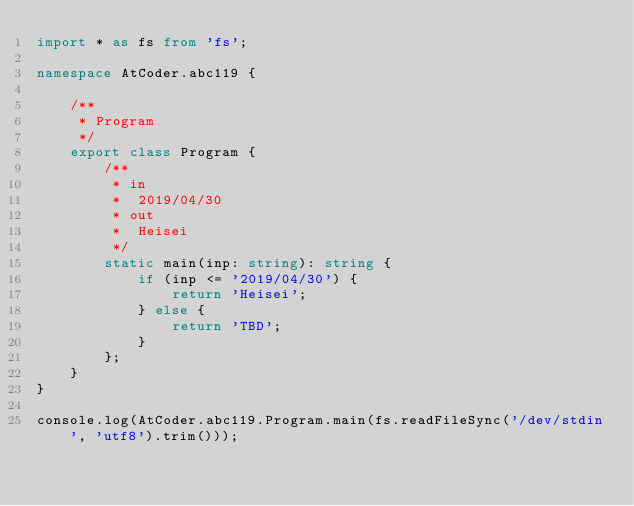Convert code to text. <code><loc_0><loc_0><loc_500><loc_500><_TypeScript_>import * as fs from 'fs';

namespace AtCoder.abc119 {

    /**
     * Program
     */
    export class Program {
        /**
         * in
         *  2019/04/30
         * out
         *  Heisei
         */
        static main(inp: string): string {
            if (inp <= '2019/04/30') {
                return 'Heisei';
            } else {
                return 'TBD';
            }
        };
    }
}

console.log(AtCoder.abc119.Program.main(fs.readFileSync('/dev/stdin', 'utf8').trim()));
</code> 